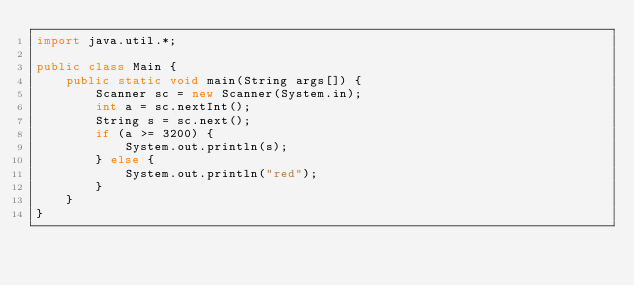Convert code to text. <code><loc_0><loc_0><loc_500><loc_500><_Java_>import java.util.*;

public class Main {
    public static void main(String args[]) {
        Scanner sc = new Scanner(System.in);
        int a = sc.nextInt();
        String s = sc.next();
        if (a >= 3200) {
            System.out.println(s);
        } else {
            System.out.println("red");
        }
    }
}
</code> 